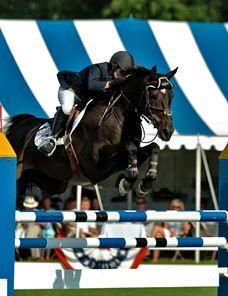How many bars is this horse jumping?
Give a very brief answer. 2. How many laptops is on the table?
Give a very brief answer. 0. 